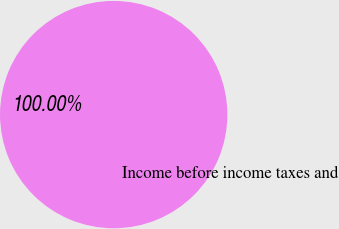Convert chart to OTSL. <chart><loc_0><loc_0><loc_500><loc_500><pie_chart><fcel>Income before income taxes and<nl><fcel>100.0%<nl></chart> 